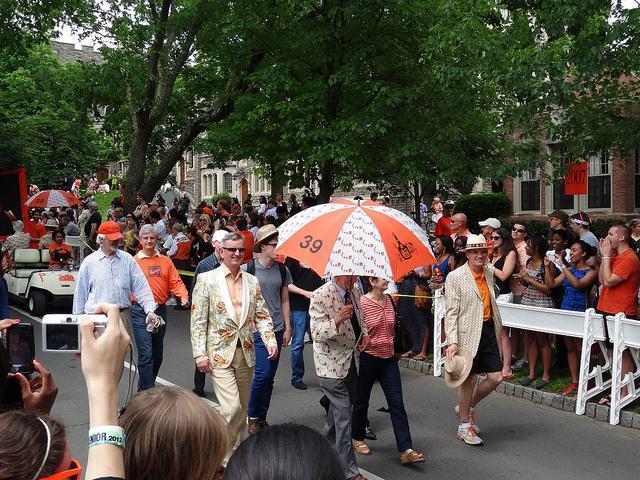What event is being filmed here?
Answer the question by selecting the correct answer among the 4 following choices.
Options: Protest, cake walk, horse show, parade. Parade. 